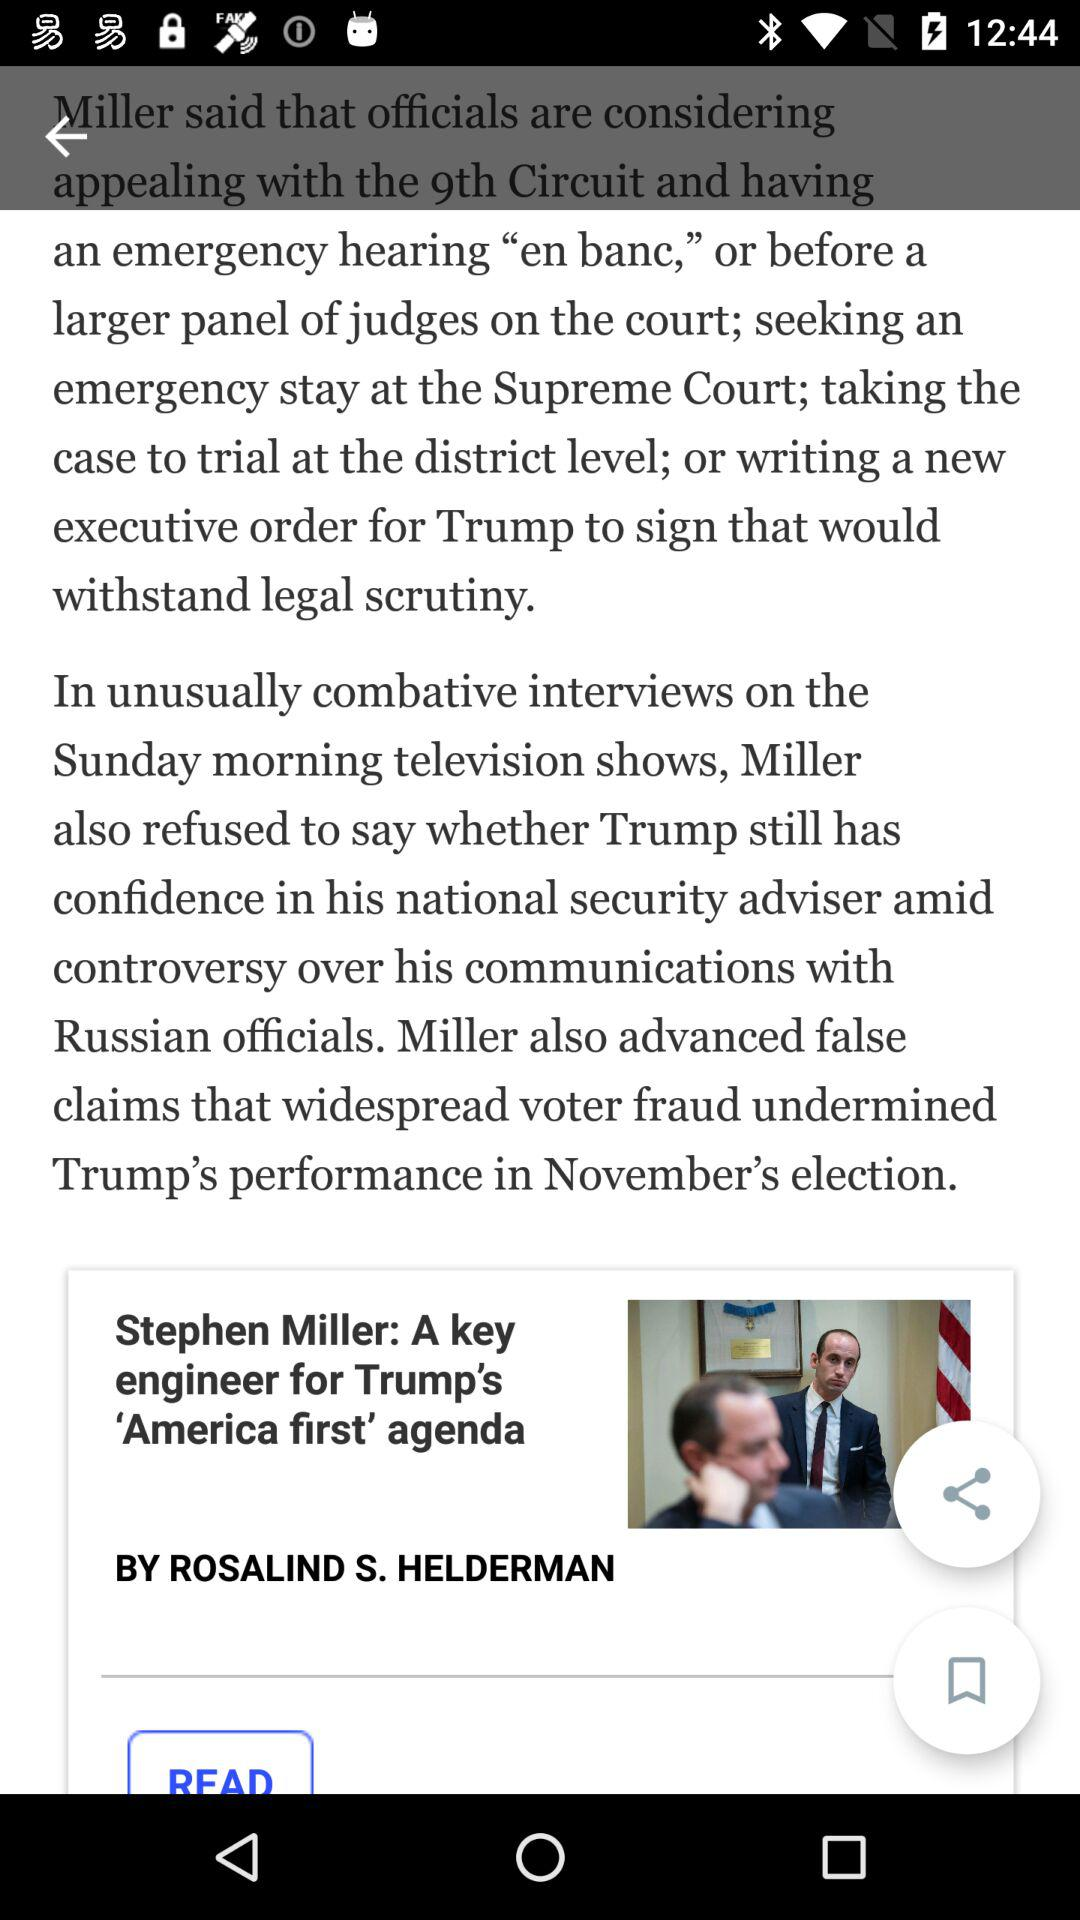Who is the author of "A key engineer for Trump's 'America first' agenda"? The author is Rosalind S. Helderman. 